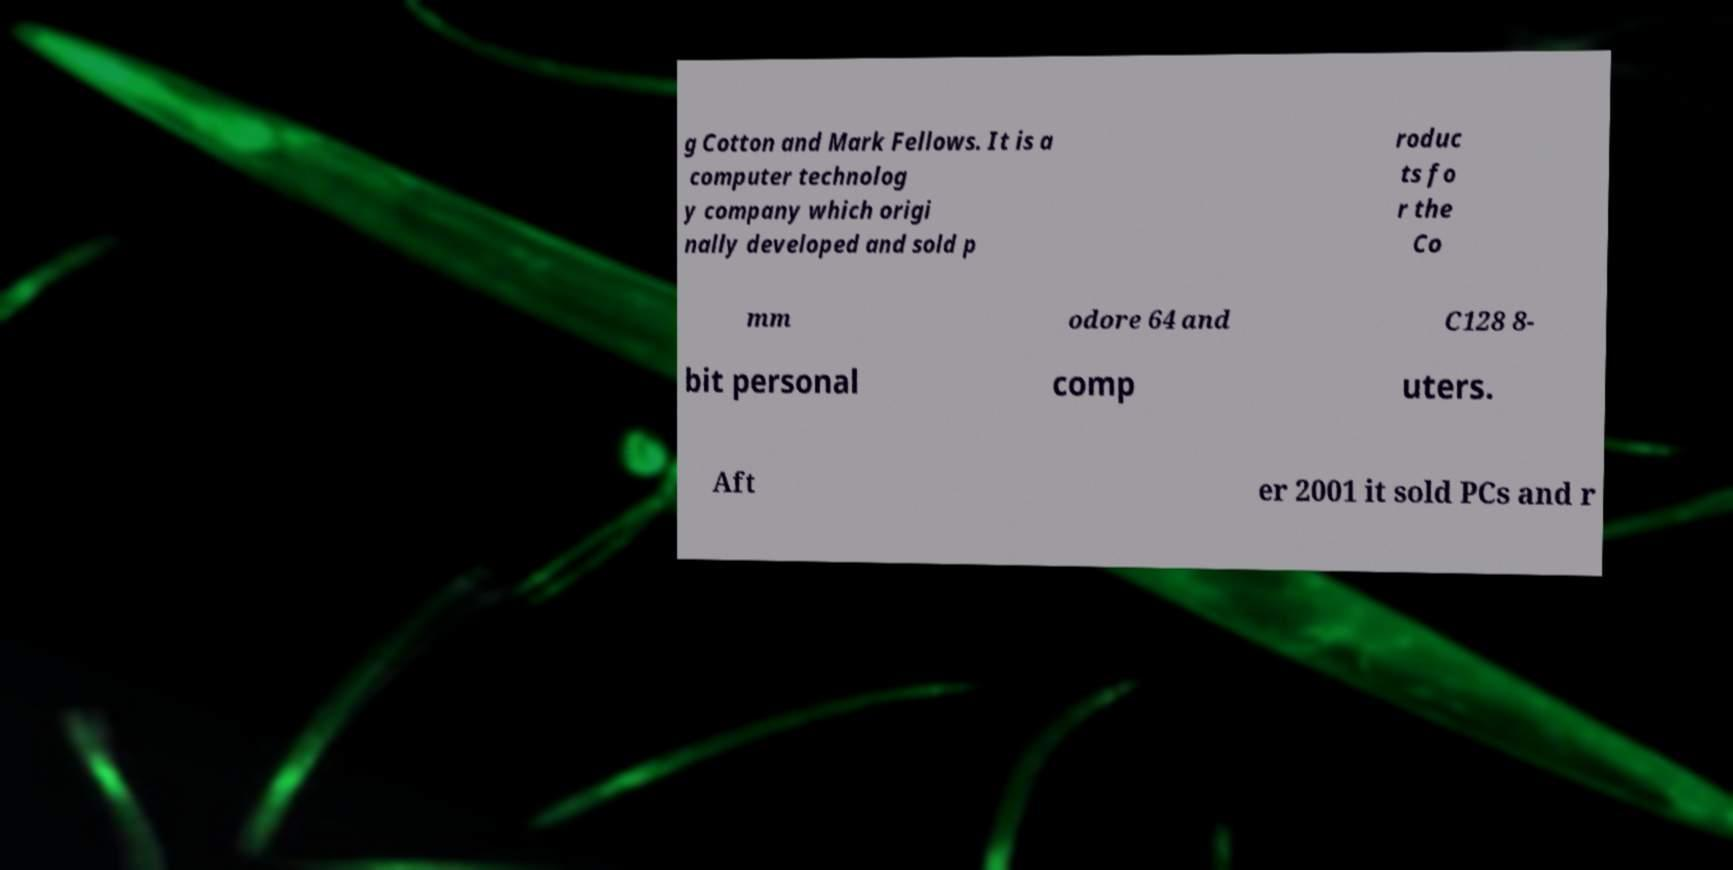For documentation purposes, I need the text within this image transcribed. Could you provide that? g Cotton and Mark Fellows. It is a computer technolog y company which origi nally developed and sold p roduc ts fo r the Co mm odore 64 and C128 8- bit personal comp uters. Aft er 2001 it sold PCs and r 